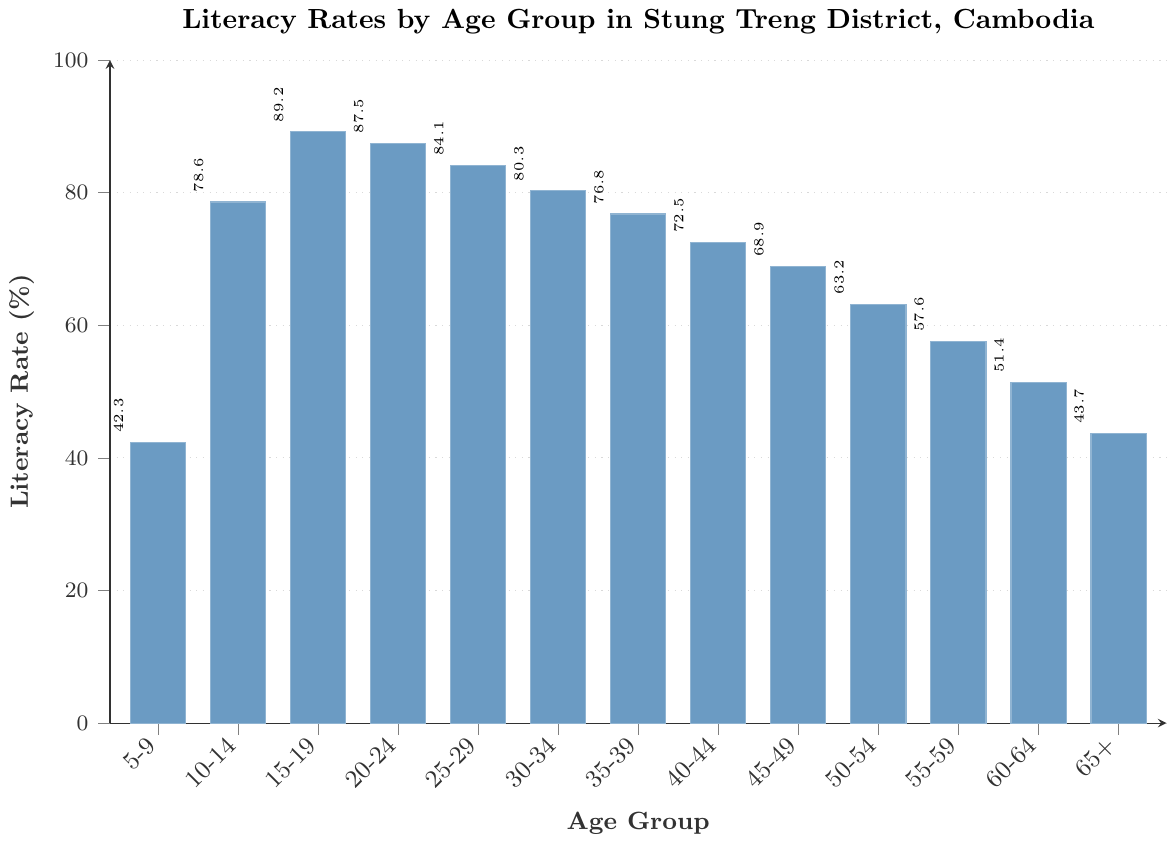Which age group has the highest literacy rate? To find the age group with the highest literacy rate, look for the tallest bar in the chart. The tallest bar corresponds to the 15-19 age group at 89.2%.
Answer: 15-19 What is the literacy rate for the 25-29 age group? Locate the bar representing the 25-29 age group and look at the value next to it. The literacy rate is 84.1%.
Answer: 84.1% Compare the literacy rates of the 5-9 and 65+ age groups. Which one is higher? Look at the bars for the 5-9 and 65+ age groups. The 5-9 age group has a literacy rate of 42.3%, and the 65+ age group has a literacy rate of 43.7%. Thus, the 65+ age group has a higher literacy rate.
Answer: 65+ By how much does the literacy rate for the 10-14 age group exceed that of the 60-64 age group? Subtract the literacy rate of the 60-64 age group (51.4%) from that of the 10-14 age group (78.6%). 78.6% - 51.4% = 27.2%.
Answer: 27.2% What is the median literacy rate among all age groups? List all literacy rates: 42.3%, 43.7%, 51.4%, 57.6%, 63.2%, 68.9%, 72.5%, 76.8%, 80.3%, 84.1%, 87.5%, 89.2%, 78.6%. Arrange in ascending order: 42.3%, 43.7%, 51.4%, 57.6%, 63.2%, 68.9%, 72.5%, 76.8%, 80.3%, 84.1%, 87.5%, 89.2%. The median (7th value) is 72.5%.
Answer: 72.5% What is the average literacy rate of the age groups from 55-59 and 60-64? Add the literacy rates of the two age groups (55-59: 57.6%, 60-64: 51.4%) and divide by 2. (57.6% + 51.4%) / 2 = 54.5%.
Answer: 54.5% Which age group shows the steepest decline in literacy rate from its preceding age group? Identify the differences between adjoining age groups and find the maximum change. Largest change is from 10-14 (78.6%) to 5-9 (42.3%), a decline of 36.3%.
Answer: 5-9 Which age group has a literacy rate closest to 70%? Compare the literacy rates of all age groups to 70%. The closest value is for the 40-44 age group at 72.5%.
Answer: 40-44 